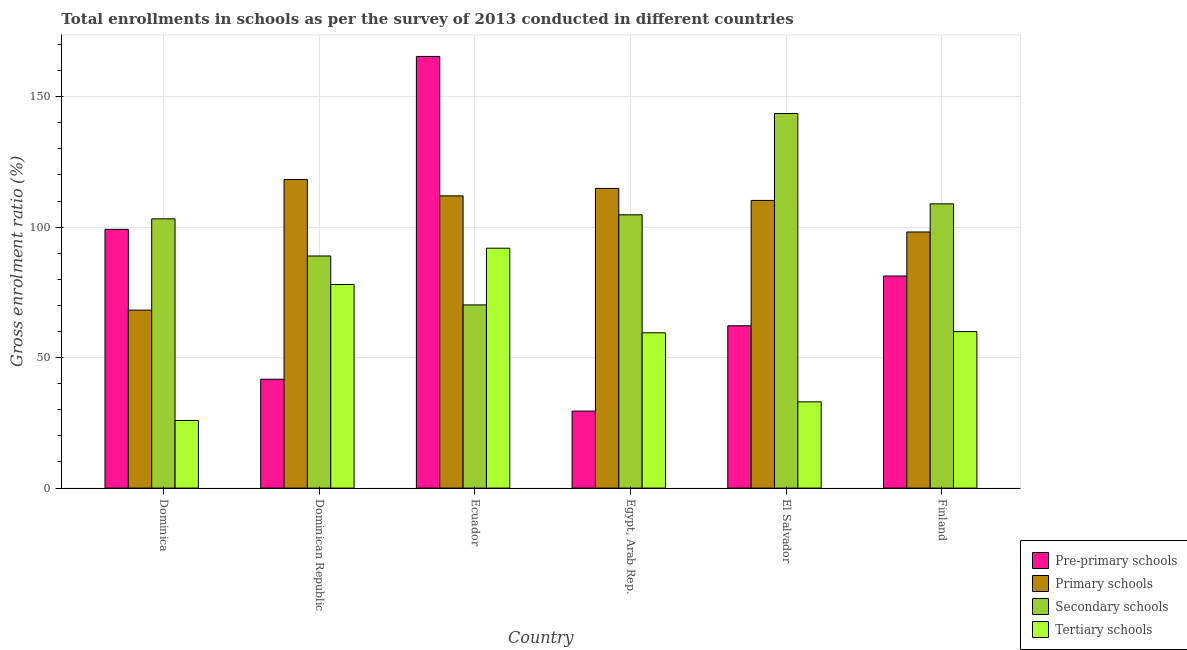How many groups of bars are there?
Offer a very short reply. 6. Are the number of bars per tick equal to the number of legend labels?
Keep it short and to the point. Yes. How many bars are there on the 2nd tick from the left?
Provide a succinct answer. 4. What is the label of the 2nd group of bars from the left?
Ensure brevity in your answer.  Dominican Republic. In how many cases, is the number of bars for a given country not equal to the number of legend labels?
Offer a terse response. 0. What is the gross enrolment ratio in tertiary schools in El Salvador?
Offer a very short reply. 33.05. Across all countries, what is the maximum gross enrolment ratio in tertiary schools?
Provide a short and direct response. 91.94. Across all countries, what is the minimum gross enrolment ratio in pre-primary schools?
Your response must be concise. 29.51. In which country was the gross enrolment ratio in primary schools maximum?
Your answer should be very brief. Dominican Republic. In which country was the gross enrolment ratio in secondary schools minimum?
Provide a short and direct response. Ecuador. What is the total gross enrolment ratio in pre-primary schools in the graph?
Your answer should be compact. 479.28. What is the difference between the gross enrolment ratio in secondary schools in Dominican Republic and that in El Salvador?
Offer a terse response. -54.6. What is the difference between the gross enrolment ratio in primary schools in Dominican Republic and the gross enrolment ratio in pre-primary schools in Egypt, Arab Rep.?
Your answer should be very brief. 88.76. What is the average gross enrolment ratio in secondary schools per country?
Ensure brevity in your answer.  103.26. What is the difference between the gross enrolment ratio in pre-primary schools and gross enrolment ratio in tertiary schools in Dominican Republic?
Ensure brevity in your answer.  -36.3. In how many countries, is the gross enrolment ratio in pre-primary schools greater than 100 %?
Offer a very short reply. 1. What is the ratio of the gross enrolment ratio in pre-primary schools in Dominica to that in Egypt, Arab Rep.?
Give a very brief answer. 3.36. What is the difference between the highest and the second highest gross enrolment ratio in tertiary schools?
Provide a succinct answer. 13.92. What is the difference between the highest and the lowest gross enrolment ratio in pre-primary schools?
Offer a terse response. 135.9. Is the sum of the gross enrolment ratio in primary schools in Ecuador and El Salvador greater than the maximum gross enrolment ratio in secondary schools across all countries?
Ensure brevity in your answer.  Yes. What does the 4th bar from the left in Dominica represents?
Provide a short and direct response. Tertiary schools. What does the 4th bar from the right in El Salvador represents?
Provide a short and direct response. Pre-primary schools. How are the legend labels stacked?
Offer a very short reply. Vertical. What is the title of the graph?
Offer a very short reply. Total enrollments in schools as per the survey of 2013 conducted in different countries. What is the Gross enrolment ratio (%) of Pre-primary schools in Dominica?
Ensure brevity in your answer.  99.15. What is the Gross enrolment ratio (%) of Primary schools in Dominica?
Give a very brief answer. 68.19. What is the Gross enrolment ratio (%) of Secondary schools in Dominica?
Make the answer very short. 103.19. What is the Gross enrolment ratio (%) of Tertiary schools in Dominica?
Keep it short and to the point. 25.92. What is the Gross enrolment ratio (%) of Pre-primary schools in Dominican Republic?
Keep it short and to the point. 41.71. What is the Gross enrolment ratio (%) of Primary schools in Dominican Republic?
Give a very brief answer. 118.27. What is the Gross enrolment ratio (%) of Secondary schools in Dominican Republic?
Give a very brief answer. 88.95. What is the Gross enrolment ratio (%) in Tertiary schools in Dominican Republic?
Provide a short and direct response. 78.02. What is the Gross enrolment ratio (%) of Pre-primary schools in Ecuador?
Give a very brief answer. 165.42. What is the Gross enrolment ratio (%) in Primary schools in Ecuador?
Make the answer very short. 111.99. What is the Gross enrolment ratio (%) of Secondary schools in Ecuador?
Your answer should be compact. 70.2. What is the Gross enrolment ratio (%) of Tertiary schools in Ecuador?
Your answer should be very brief. 91.94. What is the Gross enrolment ratio (%) of Pre-primary schools in Egypt, Arab Rep.?
Your answer should be compact. 29.51. What is the Gross enrolment ratio (%) in Primary schools in Egypt, Arab Rep.?
Offer a very short reply. 114.85. What is the Gross enrolment ratio (%) in Secondary schools in Egypt, Arab Rep.?
Offer a terse response. 104.73. What is the Gross enrolment ratio (%) in Tertiary schools in Egypt, Arab Rep.?
Offer a very short reply. 59.52. What is the Gross enrolment ratio (%) of Pre-primary schools in El Salvador?
Your response must be concise. 62.21. What is the Gross enrolment ratio (%) of Primary schools in El Salvador?
Your answer should be very brief. 110.25. What is the Gross enrolment ratio (%) in Secondary schools in El Salvador?
Your response must be concise. 143.55. What is the Gross enrolment ratio (%) in Tertiary schools in El Salvador?
Give a very brief answer. 33.05. What is the Gross enrolment ratio (%) in Pre-primary schools in Finland?
Keep it short and to the point. 81.27. What is the Gross enrolment ratio (%) of Primary schools in Finland?
Ensure brevity in your answer.  98.16. What is the Gross enrolment ratio (%) in Secondary schools in Finland?
Give a very brief answer. 108.93. What is the Gross enrolment ratio (%) of Tertiary schools in Finland?
Keep it short and to the point. 59.98. Across all countries, what is the maximum Gross enrolment ratio (%) in Pre-primary schools?
Give a very brief answer. 165.42. Across all countries, what is the maximum Gross enrolment ratio (%) in Primary schools?
Provide a succinct answer. 118.27. Across all countries, what is the maximum Gross enrolment ratio (%) of Secondary schools?
Offer a terse response. 143.55. Across all countries, what is the maximum Gross enrolment ratio (%) in Tertiary schools?
Keep it short and to the point. 91.94. Across all countries, what is the minimum Gross enrolment ratio (%) in Pre-primary schools?
Your response must be concise. 29.51. Across all countries, what is the minimum Gross enrolment ratio (%) of Primary schools?
Provide a short and direct response. 68.19. Across all countries, what is the minimum Gross enrolment ratio (%) in Secondary schools?
Ensure brevity in your answer.  70.2. Across all countries, what is the minimum Gross enrolment ratio (%) of Tertiary schools?
Keep it short and to the point. 25.92. What is the total Gross enrolment ratio (%) of Pre-primary schools in the graph?
Ensure brevity in your answer.  479.28. What is the total Gross enrolment ratio (%) of Primary schools in the graph?
Your response must be concise. 621.71. What is the total Gross enrolment ratio (%) in Secondary schools in the graph?
Your answer should be compact. 619.54. What is the total Gross enrolment ratio (%) in Tertiary schools in the graph?
Offer a very short reply. 348.42. What is the difference between the Gross enrolment ratio (%) in Pre-primary schools in Dominica and that in Dominican Republic?
Offer a very short reply. 57.44. What is the difference between the Gross enrolment ratio (%) in Primary schools in Dominica and that in Dominican Republic?
Your answer should be very brief. -50.08. What is the difference between the Gross enrolment ratio (%) of Secondary schools in Dominica and that in Dominican Republic?
Ensure brevity in your answer.  14.24. What is the difference between the Gross enrolment ratio (%) of Tertiary schools in Dominica and that in Dominican Republic?
Make the answer very short. -52.09. What is the difference between the Gross enrolment ratio (%) of Pre-primary schools in Dominica and that in Ecuador?
Give a very brief answer. -66.27. What is the difference between the Gross enrolment ratio (%) of Primary schools in Dominica and that in Ecuador?
Your response must be concise. -43.8. What is the difference between the Gross enrolment ratio (%) in Secondary schools in Dominica and that in Ecuador?
Your answer should be compact. 32.99. What is the difference between the Gross enrolment ratio (%) in Tertiary schools in Dominica and that in Ecuador?
Offer a terse response. -66.01. What is the difference between the Gross enrolment ratio (%) in Pre-primary schools in Dominica and that in Egypt, Arab Rep.?
Provide a succinct answer. 69.64. What is the difference between the Gross enrolment ratio (%) of Primary schools in Dominica and that in Egypt, Arab Rep.?
Your response must be concise. -46.66. What is the difference between the Gross enrolment ratio (%) of Secondary schools in Dominica and that in Egypt, Arab Rep.?
Give a very brief answer. -1.54. What is the difference between the Gross enrolment ratio (%) of Tertiary schools in Dominica and that in Egypt, Arab Rep.?
Offer a terse response. -33.59. What is the difference between the Gross enrolment ratio (%) of Pre-primary schools in Dominica and that in El Salvador?
Give a very brief answer. 36.94. What is the difference between the Gross enrolment ratio (%) of Primary schools in Dominica and that in El Salvador?
Your answer should be very brief. -42.06. What is the difference between the Gross enrolment ratio (%) in Secondary schools in Dominica and that in El Salvador?
Keep it short and to the point. -40.36. What is the difference between the Gross enrolment ratio (%) of Tertiary schools in Dominica and that in El Salvador?
Ensure brevity in your answer.  -7.13. What is the difference between the Gross enrolment ratio (%) of Pre-primary schools in Dominica and that in Finland?
Your answer should be very brief. 17.88. What is the difference between the Gross enrolment ratio (%) of Primary schools in Dominica and that in Finland?
Provide a short and direct response. -29.96. What is the difference between the Gross enrolment ratio (%) in Secondary schools in Dominica and that in Finland?
Give a very brief answer. -5.74. What is the difference between the Gross enrolment ratio (%) in Tertiary schools in Dominica and that in Finland?
Make the answer very short. -34.05. What is the difference between the Gross enrolment ratio (%) of Pre-primary schools in Dominican Republic and that in Ecuador?
Make the answer very short. -123.71. What is the difference between the Gross enrolment ratio (%) in Primary schools in Dominican Republic and that in Ecuador?
Make the answer very short. 6.28. What is the difference between the Gross enrolment ratio (%) of Secondary schools in Dominican Republic and that in Ecuador?
Your answer should be very brief. 18.75. What is the difference between the Gross enrolment ratio (%) of Tertiary schools in Dominican Republic and that in Ecuador?
Offer a very short reply. -13.92. What is the difference between the Gross enrolment ratio (%) in Pre-primary schools in Dominican Republic and that in Egypt, Arab Rep.?
Give a very brief answer. 12.2. What is the difference between the Gross enrolment ratio (%) of Primary schools in Dominican Republic and that in Egypt, Arab Rep.?
Your response must be concise. 3.42. What is the difference between the Gross enrolment ratio (%) in Secondary schools in Dominican Republic and that in Egypt, Arab Rep.?
Ensure brevity in your answer.  -15.78. What is the difference between the Gross enrolment ratio (%) of Tertiary schools in Dominican Republic and that in Egypt, Arab Rep.?
Your response must be concise. 18.5. What is the difference between the Gross enrolment ratio (%) of Pre-primary schools in Dominican Republic and that in El Salvador?
Make the answer very short. -20.5. What is the difference between the Gross enrolment ratio (%) in Primary schools in Dominican Republic and that in El Salvador?
Offer a terse response. 8.02. What is the difference between the Gross enrolment ratio (%) of Secondary schools in Dominican Republic and that in El Salvador?
Ensure brevity in your answer.  -54.6. What is the difference between the Gross enrolment ratio (%) in Tertiary schools in Dominican Republic and that in El Salvador?
Make the answer very short. 44.97. What is the difference between the Gross enrolment ratio (%) of Pre-primary schools in Dominican Republic and that in Finland?
Offer a terse response. -39.56. What is the difference between the Gross enrolment ratio (%) in Primary schools in Dominican Republic and that in Finland?
Provide a short and direct response. 20.12. What is the difference between the Gross enrolment ratio (%) of Secondary schools in Dominican Republic and that in Finland?
Offer a very short reply. -19.98. What is the difference between the Gross enrolment ratio (%) in Tertiary schools in Dominican Republic and that in Finland?
Offer a very short reply. 18.04. What is the difference between the Gross enrolment ratio (%) of Pre-primary schools in Ecuador and that in Egypt, Arab Rep.?
Offer a terse response. 135.9. What is the difference between the Gross enrolment ratio (%) of Primary schools in Ecuador and that in Egypt, Arab Rep.?
Your answer should be very brief. -2.86. What is the difference between the Gross enrolment ratio (%) of Secondary schools in Ecuador and that in Egypt, Arab Rep.?
Offer a terse response. -34.53. What is the difference between the Gross enrolment ratio (%) of Tertiary schools in Ecuador and that in Egypt, Arab Rep.?
Your answer should be very brief. 32.42. What is the difference between the Gross enrolment ratio (%) in Pre-primary schools in Ecuador and that in El Salvador?
Ensure brevity in your answer.  103.21. What is the difference between the Gross enrolment ratio (%) of Primary schools in Ecuador and that in El Salvador?
Ensure brevity in your answer.  1.74. What is the difference between the Gross enrolment ratio (%) in Secondary schools in Ecuador and that in El Salvador?
Your answer should be very brief. -73.35. What is the difference between the Gross enrolment ratio (%) in Tertiary schools in Ecuador and that in El Salvador?
Offer a very short reply. 58.88. What is the difference between the Gross enrolment ratio (%) of Pre-primary schools in Ecuador and that in Finland?
Your response must be concise. 84.15. What is the difference between the Gross enrolment ratio (%) in Primary schools in Ecuador and that in Finland?
Ensure brevity in your answer.  13.84. What is the difference between the Gross enrolment ratio (%) of Secondary schools in Ecuador and that in Finland?
Offer a very short reply. -38.73. What is the difference between the Gross enrolment ratio (%) of Tertiary schools in Ecuador and that in Finland?
Provide a short and direct response. 31.96. What is the difference between the Gross enrolment ratio (%) in Pre-primary schools in Egypt, Arab Rep. and that in El Salvador?
Offer a terse response. -32.7. What is the difference between the Gross enrolment ratio (%) of Primary schools in Egypt, Arab Rep. and that in El Salvador?
Provide a succinct answer. 4.6. What is the difference between the Gross enrolment ratio (%) of Secondary schools in Egypt, Arab Rep. and that in El Salvador?
Provide a short and direct response. -38.82. What is the difference between the Gross enrolment ratio (%) of Tertiary schools in Egypt, Arab Rep. and that in El Salvador?
Your answer should be very brief. 26.47. What is the difference between the Gross enrolment ratio (%) in Pre-primary schools in Egypt, Arab Rep. and that in Finland?
Offer a very short reply. -51.76. What is the difference between the Gross enrolment ratio (%) of Primary schools in Egypt, Arab Rep. and that in Finland?
Offer a terse response. 16.69. What is the difference between the Gross enrolment ratio (%) in Secondary schools in Egypt, Arab Rep. and that in Finland?
Your answer should be compact. -4.2. What is the difference between the Gross enrolment ratio (%) in Tertiary schools in Egypt, Arab Rep. and that in Finland?
Make the answer very short. -0.46. What is the difference between the Gross enrolment ratio (%) in Pre-primary schools in El Salvador and that in Finland?
Your response must be concise. -19.06. What is the difference between the Gross enrolment ratio (%) in Primary schools in El Salvador and that in Finland?
Offer a very short reply. 12.09. What is the difference between the Gross enrolment ratio (%) in Secondary schools in El Salvador and that in Finland?
Ensure brevity in your answer.  34.62. What is the difference between the Gross enrolment ratio (%) of Tertiary schools in El Salvador and that in Finland?
Ensure brevity in your answer.  -26.93. What is the difference between the Gross enrolment ratio (%) in Pre-primary schools in Dominica and the Gross enrolment ratio (%) in Primary schools in Dominican Republic?
Offer a very short reply. -19.12. What is the difference between the Gross enrolment ratio (%) of Pre-primary schools in Dominica and the Gross enrolment ratio (%) of Secondary schools in Dominican Republic?
Your answer should be compact. 10.2. What is the difference between the Gross enrolment ratio (%) in Pre-primary schools in Dominica and the Gross enrolment ratio (%) in Tertiary schools in Dominican Republic?
Keep it short and to the point. 21.13. What is the difference between the Gross enrolment ratio (%) of Primary schools in Dominica and the Gross enrolment ratio (%) of Secondary schools in Dominican Republic?
Keep it short and to the point. -20.76. What is the difference between the Gross enrolment ratio (%) of Primary schools in Dominica and the Gross enrolment ratio (%) of Tertiary schools in Dominican Republic?
Your response must be concise. -9.82. What is the difference between the Gross enrolment ratio (%) of Secondary schools in Dominica and the Gross enrolment ratio (%) of Tertiary schools in Dominican Republic?
Ensure brevity in your answer.  25.17. What is the difference between the Gross enrolment ratio (%) of Pre-primary schools in Dominica and the Gross enrolment ratio (%) of Primary schools in Ecuador?
Make the answer very short. -12.84. What is the difference between the Gross enrolment ratio (%) of Pre-primary schools in Dominica and the Gross enrolment ratio (%) of Secondary schools in Ecuador?
Offer a very short reply. 28.95. What is the difference between the Gross enrolment ratio (%) of Pre-primary schools in Dominica and the Gross enrolment ratio (%) of Tertiary schools in Ecuador?
Your response must be concise. 7.22. What is the difference between the Gross enrolment ratio (%) in Primary schools in Dominica and the Gross enrolment ratio (%) in Secondary schools in Ecuador?
Your answer should be very brief. -2.01. What is the difference between the Gross enrolment ratio (%) of Primary schools in Dominica and the Gross enrolment ratio (%) of Tertiary schools in Ecuador?
Provide a short and direct response. -23.74. What is the difference between the Gross enrolment ratio (%) of Secondary schools in Dominica and the Gross enrolment ratio (%) of Tertiary schools in Ecuador?
Your answer should be very brief. 11.25. What is the difference between the Gross enrolment ratio (%) in Pre-primary schools in Dominica and the Gross enrolment ratio (%) in Primary schools in Egypt, Arab Rep.?
Your answer should be compact. -15.7. What is the difference between the Gross enrolment ratio (%) in Pre-primary schools in Dominica and the Gross enrolment ratio (%) in Secondary schools in Egypt, Arab Rep.?
Make the answer very short. -5.58. What is the difference between the Gross enrolment ratio (%) in Pre-primary schools in Dominica and the Gross enrolment ratio (%) in Tertiary schools in Egypt, Arab Rep.?
Your response must be concise. 39.63. What is the difference between the Gross enrolment ratio (%) in Primary schools in Dominica and the Gross enrolment ratio (%) in Secondary schools in Egypt, Arab Rep.?
Make the answer very short. -36.53. What is the difference between the Gross enrolment ratio (%) in Primary schools in Dominica and the Gross enrolment ratio (%) in Tertiary schools in Egypt, Arab Rep.?
Offer a terse response. 8.67. What is the difference between the Gross enrolment ratio (%) of Secondary schools in Dominica and the Gross enrolment ratio (%) of Tertiary schools in Egypt, Arab Rep.?
Provide a short and direct response. 43.67. What is the difference between the Gross enrolment ratio (%) of Pre-primary schools in Dominica and the Gross enrolment ratio (%) of Primary schools in El Salvador?
Offer a terse response. -11.1. What is the difference between the Gross enrolment ratio (%) of Pre-primary schools in Dominica and the Gross enrolment ratio (%) of Secondary schools in El Salvador?
Give a very brief answer. -44.4. What is the difference between the Gross enrolment ratio (%) in Pre-primary schools in Dominica and the Gross enrolment ratio (%) in Tertiary schools in El Salvador?
Your answer should be very brief. 66.1. What is the difference between the Gross enrolment ratio (%) of Primary schools in Dominica and the Gross enrolment ratio (%) of Secondary schools in El Salvador?
Give a very brief answer. -75.36. What is the difference between the Gross enrolment ratio (%) in Primary schools in Dominica and the Gross enrolment ratio (%) in Tertiary schools in El Salvador?
Offer a very short reply. 35.14. What is the difference between the Gross enrolment ratio (%) in Secondary schools in Dominica and the Gross enrolment ratio (%) in Tertiary schools in El Salvador?
Make the answer very short. 70.14. What is the difference between the Gross enrolment ratio (%) in Pre-primary schools in Dominica and the Gross enrolment ratio (%) in Secondary schools in Finland?
Give a very brief answer. -9.78. What is the difference between the Gross enrolment ratio (%) of Pre-primary schools in Dominica and the Gross enrolment ratio (%) of Tertiary schools in Finland?
Give a very brief answer. 39.17. What is the difference between the Gross enrolment ratio (%) in Primary schools in Dominica and the Gross enrolment ratio (%) in Secondary schools in Finland?
Your answer should be very brief. -40.73. What is the difference between the Gross enrolment ratio (%) in Primary schools in Dominica and the Gross enrolment ratio (%) in Tertiary schools in Finland?
Offer a very short reply. 8.22. What is the difference between the Gross enrolment ratio (%) in Secondary schools in Dominica and the Gross enrolment ratio (%) in Tertiary schools in Finland?
Your response must be concise. 43.21. What is the difference between the Gross enrolment ratio (%) of Pre-primary schools in Dominican Republic and the Gross enrolment ratio (%) of Primary schools in Ecuador?
Your answer should be very brief. -70.28. What is the difference between the Gross enrolment ratio (%) of Pre-primary schools in Dominican Republic and the Gross enrolment ratio (%) of Secondary schools in Ecuador?
Offer a terse response. -28.48. What is the difference between the Gross enrolment ratio (%) in Pre-primary schools in Dominican Republic and the Gross enrolment ratio (%) in Tertiary schools in Ecuador?
Ensure brevity in your answer.  -50.22. What is the difference between the Gross enrolment ratio (%) in Primary schools in Dominican Republic and the Gross enrolment ratio (%) in Secondary schools in Ecuador?
Ensure brevity in your answer.  48.08. What is the difference between the Gross enrolment ratio (%) in Primary schools in Dominican Republic and the Gross enrolment ratio (%) in Tertiary schools in Ecuador?
Your answer should be very brief. 26.34. What is the difference between the Gross enrolment ratio (%) in Secondary schools in Dominican Republic and the Gross enrolment ratio (%) in Tertiary schools in Ecuador?
Your answer should be compact. -2.99. What is the difference between the Gross enrolment ratio (%) in Pre-primary schools in Dominican Republic and the Gross enrolment ratio (%) in Primary schools in Egypt, Arab Rep.?
Ensure brevity in your answer.  -73.13. What is the difference between the Gross enrolment ratio (%) in Pre-primary schools in Dominican Republic and the Gross enrolment ratio (%) in Secondary schools in Egypt, Arab Rep.?
Your answer should be very brief. -63.01. What is the difference between the Gross enrolment ratio (%) in Pre-primary schools in Dominican Republic and the Gross enrolment ratio (%) in Tertiary schools in Egypt, Arab Rep.?
Provide a short and direct response. -17.8. What is the difference between the Gross enrolment ratio (%) of Primary schools in Dominican Republic and the Gross enrolment ratio (%) of Secondary schools in Egypt, Arab Rep.?
Give a very brief answer. 13.55. What is the difference between the Gross enrolment ratio (%) in Primary schools in Dominican Republic and the Gross enrolment ratio (%) in Tertiary schools in Egypt, Arab Rep.?
Your answer should be very brief. 58.76. What is the difference between the Gross enrolment ratio (%) in Secondary schools in Dominican Republic and the Gross enrolment ratio (%) in Tertiary schools in Egypt, Arab Rep.?
Ensure brevity in your answer.  29.43. What is the difference between the Gross enrolment ratio (%) of Pre-primary schools in Dominican Republic and the Gross enrolment ratio (%) of Primary schools in El Salvador?
Your answer should be compact. -68.54. What is the difference between the Gross enrolment ratio (%) of Pre-primary schools in Dominican Republic and the Gross enrolment ratio (%) of Secondary schools in El Salvador?
Provide a short and direct response. -101.84. What is the difference between the Gross enrolment ratio (%) of Pre-primary schools in Dominican Republic and the Gross enrolment ratio (%) of Tertiary schools in El Salvador?
Your answer should be compact. 8.66. What is the difference between the Gross enrolment ratio (%) of Primary schools in Dominican Republic and the Gross enrolment ratio (%) of Secondary schools in El Salvador?
Provide a short and direct response. -25.28. What is the difference between the Gross enrolment ratio (%) of Primary schools in Dominican Republic and the Gross enrolment ratio (%) of Tertiary schools in El Salvador?
Provide a short and direct response. 85.22. What is the difference between the Gross enrolment ratio (%) of Secondary schools in Dominican Republic and the Gross enrolment ratio (%) of Tertiary schools in El Salvador?
Your answer should be compact. 55.9. What is the difference between the Gross enrolment ratio (%) of Pre-primary schools in Dominican Republic and the Gross enrolment ratio (%) of Primary schools in Finland?
Make the answer very short. -56.44. What is the difference between the Gross enrolment ratio (%) of Pre-primary schools in Dominican Republic and the Gross enrolment ratio (%) of Secondary schools in Finland?
Keep it short and to the point. -67.21. What is the difference between the Gross enrolment ratio (%) of Pre-primary schools in Dominican Republic and the Gross enrolment ratio (%) of Tertiary schools in Finland?
Your response must be concise. -18.26. What is the difference between the Gross enrolment ratio (%) of Primary schools in Dominican Republic and the Gross enrolment ratio (%) of Secondary schools in Finland?
Make the answer very short. 9.35. What is the difference between the Gross enrolment ratio (%) of Primary schools in Dominican Republic and the Gross enrolment ratio (%) of Tertiary schools in Finland?
Ensure brevity in your answer.  58.3. What is the difference between the Gross enrolment ratio (%) in Secondary schools in Dominican Republic and the Gross enrolment ratio (%) in Tertiary schools in Finland?
Offer a very short reply. 28.97. What is the difference between the Gross enrolment ratio (%) of Pre-primary schools in Ecuador and the Gross enrolment ratio (%) of Primary schools in Egypt, Arab Rep.?
Ensure brevity in your answer.  50.57. What is the difference between the Gross enrolment ratio (%) in Pre-primary schools in Ecuador and the Gross enrolment ratio (%) in Secondary schools in Egypt, Arab Rep.?
Give a very brief answer. 60.69. What is the difference between the Gross enrolment ratio (%) of Pre-primary schools in Ecuador and the Gross enrolment ratio (%) of Tertiary schools in Egypt, Arab Rep.?
Give a very brief answer. 105.9. What is the difference between the Gross enrolment ratio (%) in Primary schools in Ecuador and the Gross enrolment ratio (%) in Secondary schools in Egypt, Arab Rep.?
Offer a very short reply. 7.27. What is the difference between the Gross enrolment ratio (%) of Primary schools in Ecuador and the Gross enrolment ratio (%) of Tertiary schools in Egypt, Arab Rep.?
Provide a short and direct response. 52.47. What is the difference between the Gross enrolment ratio (%) of Secondary schools in Ecuador and the Gross enrolment ratio (%) of Tertiary schools in Egypt, Arab Rep.?
Offer a very short reply. 10.68. What is the difference between the Gross enrolment ratio (%) of Pre-primary schools in Ecuador and the Gross enrolment ratio (%) of Primary schools in El Salvador?
Offer a very short reply. 55.17. What is the difference between the Gross enrolment ratio (%) of Pre-primary schools in Ecuador and the Gross enrolment ratio (%) of Secondary schools in El Salvador?
Offer a terse response. 21.87. What is the difference between the Gross enrolment ratio (%) in Pre-primary schools in Ecuador and the Gross enrolment ratio (%) in Tertiary schools in El Salvador?
Keep it short and to the point. 132.37. What is the difference between the Gross enrolment ratio (%) in Primary schools in Ecuador and the Gross enrolment ratio (%) in Secondary schools in El Salvador?
Provide a short and direct response. -31.56. What is the difference between the Gross enrolment ratio (%) of Primary schools in Ecuador and the Gross enrolment ratio (%) of Tertiary schools in El Salvador?
Make the answer very short. 78.94. What is the difference between the Gross enrolment ratio (%) in Secondary schools in Ecuador and the Gross enrolment ratio (%) in Tertiary schools in El Salvador?
Your response must be concise. 37.15. What is the difference between the Gross enrolment ratio (%) of Pre-primary schools in Ecuador and the Gross enrolment ratio (%) of Primary schools in Finland?
Offer a terse response. 67.26. What is the difference between the Gross enrolment ratio (%) in Pre-primary schools in Ecuador and the Gross enrolment ratio (%) in Secondary schools in Finland?
Offer a terse response. 56.49. What is the difference between the Gross enrolment ratio (%) in Pre-primary schools in Ecuador and the Gross enrolment ratio (%) in Tertiary schools in Finland?
Offer a very short reply. 105.44. What is the difference between the Gross enrolment ratio (%) in Primary schools in Ecuador and the Gross enrolment ratio (%) in Secondary schools in Finland?
Provide a short and direct response. 3.06. What is the difference between the Gross enrolment ratio (%) of Primary schools in Ecuador and the Gross enrolment ratio (%) of Tertiary schools in Finland?
Provide a succinct answer. 52.02. What is the difference between the Gross enrolment ratio (%) of Secondary schools in Ecuador and the Gross enrolment ratio (%) of Tertiary schools in Finland?
Make the answer very short. 10.22. What is the difference between the Gross enrolment ratio (%) of Pre-primary schools in Egypt, Arab Rep. and the Gross enrolment ratio (%) of Primary schools in El Salvador?
Provide a succinct answer. -80.73. What is the difference between the Gross enrolment ratio (%) of Pre-primary schools in Egypt, Arab Rep. and the Gross enrolment ratio (%) of Secondary schools in El Salvador?
Ensure brevity in your answer.  -114.03. What is the difference between the Gross enrolment ratio (%) in Pre-primary schools in Egypt, Arab Rep. and the Gross enrolment ratio (%) in Tertiary schools in El Salvador?
Your answer should be compact. -3.54. What is the difference between the Gross enrolment ratio (%) in Primary schools in Egypt, Arab Rep. and the Gross enrolment ratio (%) in Secondary schools in El Salvador?
Give a very brief answer. -28.7. What is the difference between the Gross enrolment ratio (%) of Primary schools in Egypt, Arab Rep. and the Gross enrolment ratio (%) of Tertiary schools in El Salvador?
Make the answer very short. 81.8. What is the difference between the Gross enrolment ratio (%) in Secondary schools in Egypt, Arab Rep. and the Gross enrolment ratio (%) in Tertiary schools in El Salvador?
Your answer should be very brief. 71.67. What is the difference between the Gross enrolment ratio (%) of Pre-primary schools in Egypt, Arab Rep. and the Gross enrolment ratio (%) of Primary schools in Finland?
Keep it short and to the point. -68.64. What is the difference between the Gross enrolment ratio (%) of Pre-primary schools in Egypt, Arab Rep. and the Gross enrolment ratio (%) of Secondary schools in Finland?
Offer a terse response. -79.41. What is the difference between the Gross enrolment ratio (%) in Pre-primary schools in Egypt, Arab Rep. and the Gross enrolment ratio (%) in Tertiary schools in Finland?
Offer a very short reply. -30.46. What is the difference between the Gross enrolment ratio (%) of Primary schools in Egypt, Arab Rep. and the Gross enrolment ratio (%) of Secondary schools in Finland?
Offer a terse response. 5.92. What is the difference between the Gross enrolment ratio (%) in Primary schools in Egypt, Arab Rep. and the Gross enrolment ratio (%) in Tertiary schools in Finland?
Provide a succinct answer. 54.87. What is the difference between the Gross enrolment ratio (%) of Secondary schools in Egypt, Arab Rep. and the Gross enrolment ratio (%) of Tertiary schools in Finland?
Keep it short and to the point. 44.75. What is the difference between the Gross enrolment ratio (%) in Pre-primary schools in El Salvador and the Gross enrolment ratio (%) in Primary schools in Finland?
Keep it short and to the point. -35.94. What is the difference between the Gross enrolment ratio (%) in Pre-primary schools in El Salvador and the Gross enrolment ratio (%) in Secondary schools in Finland?
Your response must be concise. -46.71. What is the difference between the Gross enrolment ratio (%) of Pre-primary schools in El Salvador and the Gross enrolment ratio (%) of Tertiary schools in Finland?
Keep it short and to the point. 2.24. What is the difference between the Gross enrolment ratio (%) of Primary schools in El Salvador and the Gross enrolment ratio (%) of Secondary schools in Finland?
Offer a terse response. 1.32. What is the difference between the Gross enrolment ratio (%) in Primary schools in El Salvador and the Gross enrolment ratio (%) in Tertiary schools in Finland?
Ensure brevity in your answer.  50.27. What is the difference between the Gross enrolment ratio (%) in Secondary schools in El Salvador and the Gross enrolment ratio (%) in Tertiary schools in Finland?
Keep it short and to the point. 83.57. What is the average Gross enrolment ratio (%) in Pre-primary schools per country?
Offer a terse response. 79.88. What is the average Gross enrolment ratio (%) of Primary schools per country?
Offer a terse response. 103.62. What is the average Gross enrolment ratio (%) of Secondary schools per country?
Give a very brief answer. 103.26. What is the average Gross enrolment ratio (%) of Tertiary schools per country?
Give a very brief answer. 58.07. What is the difference between the Gross enrolment ratio (%) of Pre-primary schools and Gross enrolment ratio (%) of Primary schools in Dominica?
Give a very brief answer. 30.96. What is the difference between the Gross enrolment ratio (%) of Pre-primary schools and Gross enrolment ratio (%) of Secondary schools in Dominica?
Your answer should be compact. -4.04. What is the difference between the Gross enrolment ratio (%) of Pre-primary schools and Gross enrolment ratio (%) of Tertiary schools in Dominica?
Make the answer very short. 73.23. What is the difference between the Gross enrolment ratio (%) of Primary schools and Gross enrolment ratio (%) of Secondary schools in Dominica?
Give a very brief answer. -35. What is the difference between the Gross enrolment ratio (%) in Primary schools and Gross enrolment ratio (%) in Tertiary schools in Dominica?
Provide a succinct answer. 42.27. What is the difference between the Gross enrolment ratio (%) of Secondary schools and Gross enrolment ratio (%) of Tertiary schools in Dominica?
Your response must be concise. 77.27. What is the difference between the Gross enrolment ratio (%) in Pre-primary schools and Gross enrolment ratio (%) in Primary schools in Dominican Republic?
Your answer should be compact. -76.56. What is the difference between the Gross enrolment ratio (%) of Pre-primary schools and Gross enrolment ratio (%) of Secondary schools in Dominican Republic?
Offer a very short reply. -47.24. What is the difference between the Gross enrolment ratio (%) of Pre-primary schools and Gross enrolment ratio (%) of Tertiary schools in Dominican Republic?
Offer a terse response. -36.3. What is the difference between the Gross enrolment ratio (%) of Primary schools and Gross enrolment ratio (%) of Secondary schools in Dominican Republic?
Your response must be concise. 29.32. What is the difference between the Gross enrolment ratio (%) in Primary schools and Gross enrolment ratio (%) in Tertiary schools in Dominican Republic?
Make the answer very short. 40.26. What is the difference between the Gross enrolment ratio (%) of Secondary schools and Gross enrolment ratio (%) of Tertiary schools in Dominican Republic?
Provide a succinct answer. 10.93. What is the difference between the Gross enrolment ratio (%) of Pre-primary schools and Gross enrolment ratio (%) of Primary schools in Ecuador?
Your answer should be very brief. 53.43. What is the difference between the Gross enrolment ratio (%) in Pre-primary schools and Gross enrolment ratio (%) in Secondary schools in Ecuador?
Give a very brief answer. 95.22. What is the difference between the Gross enrolment ratio (%) of Pre-primary schools and Gross enrolment ratio (%) of Tertiary schools in Ecuador?
Keep it short and to the point. 73.48. What is the difference between the Gross enrolment ratio (%) in Primary schools and Gross enrolment ratio (%) in Secondary schools in Ecuador?
Make the answer very short. 41.79. What is the difference between the Gross enrolment ratio (%) in Primary schools and Gross enrolment ratio (%) in Tertiary schools in Ecuador?
Offer a very short reply. 20.06. What is the difference between the Gross enrolment ratio (%) in Secondary schools and Gross enrolment ratio (%) in Tertiary schools in Ecuador?
Your answer should be very brief. -21.74. What is the difference between the Gross enrolment ratio (%) in Pre-primary schools and Gross enrolment ratio (%) in Primary schools in Egypt, Arab Rep.?
Your response must be concise. -85.33. What is the difference between the Gross enrolment ratio (%) in Pre-primary schools and Gross enrolment ratio (%) in Secondary schools in Egypt, Arab Rep.?
Offer a very short reply. -75.21. What is the difference between the Gross enrolment ratio (%) in Pre-primary schools and Gross enrolment ratio (%) in Tertiary schools in Egypt, Arab Rep.?
Your answer should be compact. -30. What is the difference between the Gross enrolment ratio (%) in Primary schools and Gross enrolment ratio (%) in Secondary schools in Egypt, Arab Rep.?
Ensure brevity in your answer.  10.12. What is the difference between the Gross enrolment ratio (%) of Primary schools and Gross enrolment ratio (%) of Tertiary schools in Egypt, Arab Rep.?
Provide a short and direct response. 55.33. What is the difference between the Gross enrolment ratio (%) of Secondary schools and Gross enrolment ratio (%) of Tertiary schools in Egypt, Arab Rep.?
Offer a very short reply. 45.21. What is the difference between the Gross enrolment ratio (%) of Pre-primary schools and Gross enrolment ratio (%) of Primary schools in El Salvador?
Make the answer very short. -48.04. What is the difference between the Gross enrolment ratio (%) of Pre-primary schools and Gross enrolment ratio (%) of Secondary schools in El Salvador?
Give a very brief answer. -81.34. What is the difference between the Gross enrolment ratio (%) of Pre-primary schools and Gross enrolment ratio (%) of Tertiary schools in El Salvador?
Your answer should be compact. 29.16. What is the difference between the Gross enrolment ratio (%) of Primary schools and Gross enrolment ratio (%) of Secondary schools in El Salvador?
Give a very brief answer. -33.3. What is the difference between the Gross enrolment ratio (%) of Primary schools and Gross enrolment ratio (%) of Tertiary schools in El Salvador?
Make the answer very short. 77.2. What is the difference between the Gross enrolment ratio (%) of Secondary schools and Gross enrolment ratio (%) of Tertiary schools in El Salvador?
Offer a very short reply. 110.5. What is the difference between the Gross enrolment ratio (%) in Pre-primary schools and Gross enrolment ratio (%) in Primary schools in Finland?
Make the answer very short. -16.88. What is the difference between the Gross enrolment ratio (%) in Pre-primary schools and Gross enrolment ratio (%) in Secondary schools in Finland?
Your answer should be compact. -27.66. What is the difference between the Gross enrolment ratio (%) in Pre-primary schools and Gross enrolment ratio (%) in Tertiary schools in Finland?
Your answer should be very brief. 21.3. What is the difference between the Gross enrolment ratio (%) in Primary schools and Gross enrolment ratio (%) in Secondary schools in Finland?
Offer a terse response. -10.77. What is the difference between the Gross enrolment ratio (%) in Primary schools and Gross enrolment ratio (%) in Tertiary schools in Finland?
Ensure brevity in your answer.  38.18. What is the difference between the Gross enrolment ratio (%) in Secondary schools and Gross enrolment ratio (%) in Tertiary schools in Finland?
Offer a terse response. 48.95. What is the ratio of the Gross enrolment ratio (%) of Pre-primary schools in Dominica to that in Dominican Republic?
Keep it short and to the point. 2.38. What is the ratio of the Gross enrolment ratio (%) in Primary schools in Dominica to that in Dominican Republic?
Give a very brief answer. 0.58. What is the ratio of the Gross enrolment ratio (%) in Secondary schools in Dominica to that in Dominican Republic?
Offer a very short reply. 1.16. What is the ratio of the Gross enrolment ratio (%) in Tertiary schools in Dominica to that in Dominican Republic?
Keep it short and to the point. 0.33. What is the ratio of the Gross enrolment ratio (%) of Pre-primary schools in Dominica to that in Ecuador?
Your response must be concise. 0.6. What is the ratio of the Gross enrolment ratio (%) in Primary schools in Dominica to that in Ecuador?
Provide a succinct answer. 0.61. What is the ratio of the Gross enrolment ratio (%) in Secondary schools in Dominica to that in Ecuador?
Your answer should be compact. 1.47. What is the ratio of the Gross enrolment ratio (%) of Tertiary schools in Dominica to that in Ecuador?
Your answer should be very brief. 0.28. What is the ratio of the Gross enrolment ratio (%) of Pre-primary schools in Dominica to that in Egypt, Arab Rep.?
Provide a short and direct response. 3.36. What is the ratio of the Gross enrolment ratio (%) of Primary schools in Dominica to that in Egypt, Arab Rep.?
Provide a short and direct response. 0.59. What is the ratio of the Gross enrolment ratio (%) of Secondary schools in Dominica to that in Egypt, Arab Rep.?
Offer a very short reply. 0.99. What is the ratio of the Gross enrolment ratio (%) of Tertiary schools in Dominica to that in Egypt, Arab Rep.?
Provide a succinct answer. 0.44. What is the ratio of the Gross enrolment ratio (%) in Pre-primary schools in Dominica to that in El Salvador?
Your response must be concise. 1.59. What is the ratio of the Gross enrolment ratio (%) in Primary schools in Dominica to that in El Salvador?
Give a very brief answer. 0.62. What is the ratio of the Gross enrolment ratio (%) in Secondary schools in Dominica to that in El Salvador?
Offer a terse response. 0.72. What is the ratio of the Gross enrolment ratio (%) in Tertiary schools in Dominica to that in El Salvador?
Offer a very short reply. 0.78. What is the ratio of the Gross enrolment ratio (%) in Pre-primary schools in Dominica to that in Finland?
Your answer should be compact. 1.22. What is the ratio of the Gross enrolment ratio (%) in Primary schools in Dominica to that in Finland?
Offer a very short reply. 0.69. What is the ratio of the Gross enrolment ratio (%) of Secondary schools in Dominica to that in Finland?
Your response must be concise. 0.95. What is the ratio of the Gross enrolment ratio (%) in Tertiary schools in Dominica to that in Finland?
Your answer should be very brief. 0.43. What is the ratio of the Gross enrolment ratio (%) of Pre-primary schools in Dominican Republic to that in Ecuador?
Keep it short and to the point. 0.25. What is the ratio of the Gross enrolment ratio (%) in Primary schools in Dominican Republic to that in Ecuador?
Keep it short and to the point. 1.06. What is the ratio of the Gross enrolment ratio (%) in Secondary schools in Dominican Republic to that in Ecuador?
Offer a very short reply. 1.27. What is the ratio of the Gross enrolment ratio (%) of Tertiary schools in Dominican Republic to that in Ecuador?
Your answer should be very brief. 0.85. What is the ratio of the Gross enrolment ratio (%) in Pre-primary schools in Dominican Republic to that in Egypt, Arab Rep.?
Make the answer very short. 1.41. What is the ratio of the Gross enrolment ratio (%) of Primary schools in Dominican Republic to that in Egypt, Arab Rep.?
Give a very brief answer. 1.03. What is the ratio of the Gross enrolment ratio (%) of Secondary schools in Dominican Republic to that in Egypt, Arab Rep.?
Make the answer very short. 0.85. What is the ratio of the Gross enrolment ratio (%) in Tertiary schools in Dominican Republic to that in Egypt, Arab Rep.?
Provide a short and direct response. 1.31. What is the ratio of the Gross enrolment ratio (%) of Pre-primary schools in Dominican Republic to that in El Salvador?
Your answer should be very brief. 0.67. What is the ratio of the Gross enrolment ratio (%) of Primary schools in Dominican Republic to that in El Salvador?
Keep it short and to the point. 1.07. What is the ratio of the Gross enrolment ratio (%) in Secondary schools in Dominican Republic to that in El Salvador?
Ensure brevity in your answer.  0.62. What is the ratio of the Gross enrolment ratio (%) in Tertiary schools in Dominican Republic to that in El Salvador?
Make the answer very short. 2.36. What is the ratio of the Gross enrolment ratio (%) of Pre-primary schools in Dominican Republic to that in Finland?
Provide a short and direct response. 0.51. What is the ratio of the Gross enrolment ratio (%) in Primary schools in Dominican Republic to that in Finland?
Offer a very short reply. 1.21. What is the ratio of the Gross enrolment ratio (%) of Secondary schools in Dominican Republic to that in Finland?
Offer a very short reply. 0.82. What is the ratio of the Gross enrolment ratio (%) of Tertiary schools in Dominican Republic to that in Finland?
Your answer should be compact. 1.3. What is the ratio of the Gross enrolment ratio (%) of Pre-primary schools in Ecuador to that in Egypt, Arab Rep.?
Keep it short and to the point. 5.6. What is the ratio of the Gross enrolment ratio (%) in Primary schools in Ecuador to that in Egypt, Arab Rep.?
Keep it short and to the point. 0.98. What is the ratio of the Gross enrolment ratio (%) in Secondary schools in Ecuador to that in Egypt, Arab Rep.?
Ensure brevity in your answer.  0.67. What is the ratio of the Gross enrolment ratio (%) in Tertiary schools in Ecuador to that in Egypt, Arab Rep.?
Offer a terse response. 1.54. What is the ratio of the Gross enrolment ratio (%) in Pre-primary schools in Ecuador to that in El Salvador?
Make the answer very short. 2.66. What is the ratio of the Gross enrolment ratio (%) of Primary schools in Ecuador to that in El Salvador?
Your response must be concise. 1.02. What is the ratio of the Gross enrolment ratio (%) in Secondary schools in Ecuador to that in El Salvador?
Keep it short and to the point. 0.49. What is the ratio of the Gross enrolment ratio (%) in Tertiary schools in Ecuador to that in El Salvador?
Provide a short and direct response. 2.78. What is the ratio of the Gross enrolment ratio (%) in Pre-primary schools in Ecuador to that in Finland?
Your response must be concise. 2.04. What is the ratio of the Gross enrolment ratio (%) of Primary schools in Ecuador to that in Finland?
Provide a succinct answer. 1.14. What is the ratio of the Gross enrolment ratio (%) in Secondary schools in Ecuador to that in Finland?
Provide a short and direct response. 0.64. What is the ratio of the Gross enrolment ratio (%) of Tertiary schools in Ecuador to that in Finland?
Offer a very short reply. 1.53. What is the ratio of the Gross enrolment ratio (%) of Pre-primary schools in Egypt, Arab Rep. to that in El Salvador?
Your answer should be very brief. 0.47. What is the ratio of the Gross enrolment ratio (%) of Primary schools in Egypt, Arab Rep. to that in El Salvador?
Give a very brief answer. 1.04. What is the ratio of the Gross enrolment ratio (%) of Secondary schools in Egypt, Arab Rep. to that in El Salvador?
Provide a succinct answer. 0.73. What is the ratio of the Gross enrolment ratio (%) in Tertiary schools in Egypt, Arab Rep. to that in El Salvador?
Keep it short and to the point. 1.8. What is the ratio of the Gross enrolment ratio (%) in Pre-primary schools in Egypt, Arab Rep. to that in Finland?
Offer a very short reply. 0.36. What is the ratio of the Gross enrolment ratio (%) of Primary schools in Egypt, Arab Rep. to that in Finland?
Keep it short and to the point. 1.17. What is the ratio of the Gross enrolment ratio (%) in Secondary schools in Egypt, Arab Rep. to that in Finland?
Ensure brevity in your answer.  0.96. What is the ratio of the Gross enrolment ratio (%) of Pre-primary schools in El Salvador to that in Finland?
Keep it short and to the point. 0.77. What is the ratio of the Gross enrolment ratio (%) of Primary schools in El Salvador to that in Finland?
Offer a very short reply. 1.12. What is the ratio of the Gross enrolment ratio (%) of Secondary schools in El Salvador to that in Finland?
Provide a succinct answer. 1.32. What is the ratio of the Gross enrolment ratio (%) of Tertiary schools in El Salvador to that in Finland?
Keep it short and to the point. 0.55. What is the difference between the highest and the second highest Gross enrolment ratio (%) in Pre-primary schools?
Your response must be concise. 66.27. What is the difference between the highest and the second highest Gross enrolment ratio (%) of Primary schools?
Your answer should be very brief. 3.42. What is the difference between the highest and the second highest Gross enrolment ratio (%) of Secondary schools?
Make the answer very short. 34.62. What is the difference between the highest and the second highest Gross enrolment ratio (%) of Tertiary schools?
Your answer should be compact. 13.92. What is the difference between the highest and the lowest Gross enrolment ratio (%) in Pre-primary schools?
Offer a terse response. 135.9. What is the difference between the highest and the lowest Gross enrolment ratio (%) of Primary schools?
Offer a terse response. 50.08. What is the difference between the highest and the lowest Gross enrolment ratio (%) in Secondary schools?
Your response must be concise. 73.35. What is the difference between the highest and the lowest Gross enrolment ratio (%) of Tertiary schools?
Keep it short and to the point. 66.01. 